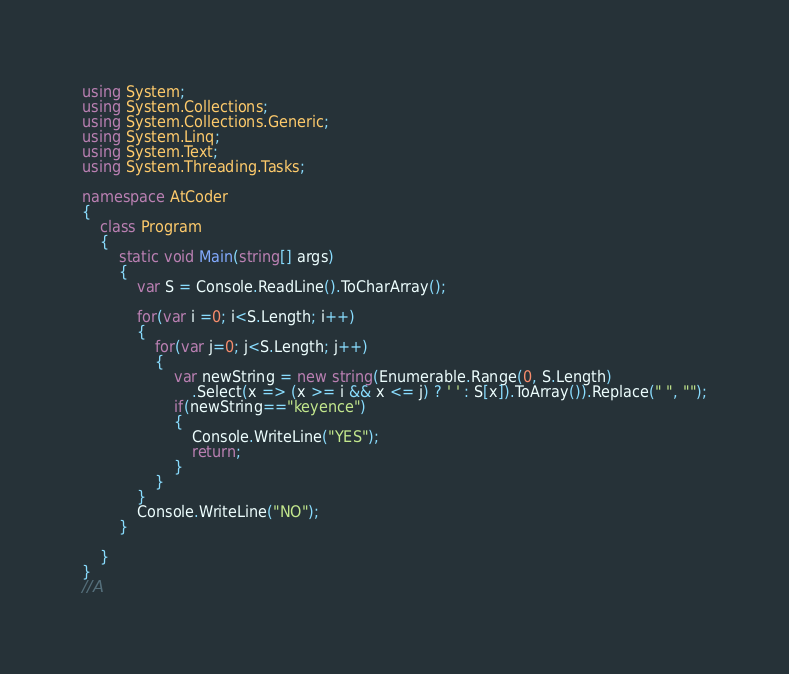Convert code to text. <code><loc_0><loc_0><loc_500><loc_500><_C#_>using System;
using System.Collections;
using System.Collections.Generic;
using System.Linq;
using System.Text;
using System.Threading.Tasks;

namespace AtCoder
{
    class Program
    {
        static void Main(string[] args)
        {
            var S = Console.ReadLine().ToCharArray();

            for(var i =0; i<S.Length; i++)
            {
                for(var j=0; j<S.Length; j++)
                {
                    var newString = new string(Enumerable.Range(0, S.Length)
                        .Select(x => (x >= i && x <= j) ? ' ' : S[x]).ToArray()).Replace(" ", "");
                    if(newString=="keyence")
                    {
                        Console.WriteLine("YES");
                        return;
                    }
                }
            }
            Console.WriteLine("NO");
        }

    }
}
//A</code> 